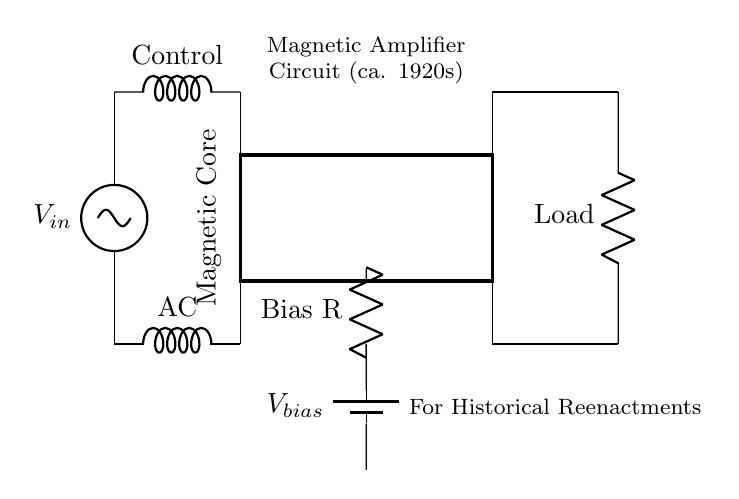What is the input voltage in the circuit? The input voltage is denoted as \( V_{in} \) at the top of the circuit diagram, indicating the point where the voltage source connects.
Answer: \( V_{in} \) What is the load component in the circuit? The load component is represented by the resistor symbol labeled as "Load," which connects at the output of the circuit.
Answer: Load What component is responsible for AC input? The component responsible for AC input is the inductor labeled as "AC," which connects to the input voltage source and is situated near the bottom of the circuit.
Answer: AC What type of amplifier is depicted in this circuit? The circuit represents a magnetic amplifier, as indicated by the title at the top and the presence of a magnetic core in the design.
Answer: Magnetic amplifier How does the control winding connect in the circuit? The control winding, labeled as "Control," connects from the AS indicated line, down to the magnetic core and then connects to the magnetic core's upper section.
Answer: Through the magnetic core What is the purpose of the battery labeled \( V_{bias} \)? The battery labeled \( V_{bias} \) provides a DC bias to influence the operation of the magnetic amplifier, connected through a resistor in the circuit.
Answer: Provide DC bias Why is the magnetic core crucial in this circuit? The magnetic core allows the control of AC and responds to input variations, amplifying the control signal to the output load; it is essential for the operation of magnetic amplifiers.
Answer: Allows signal control 